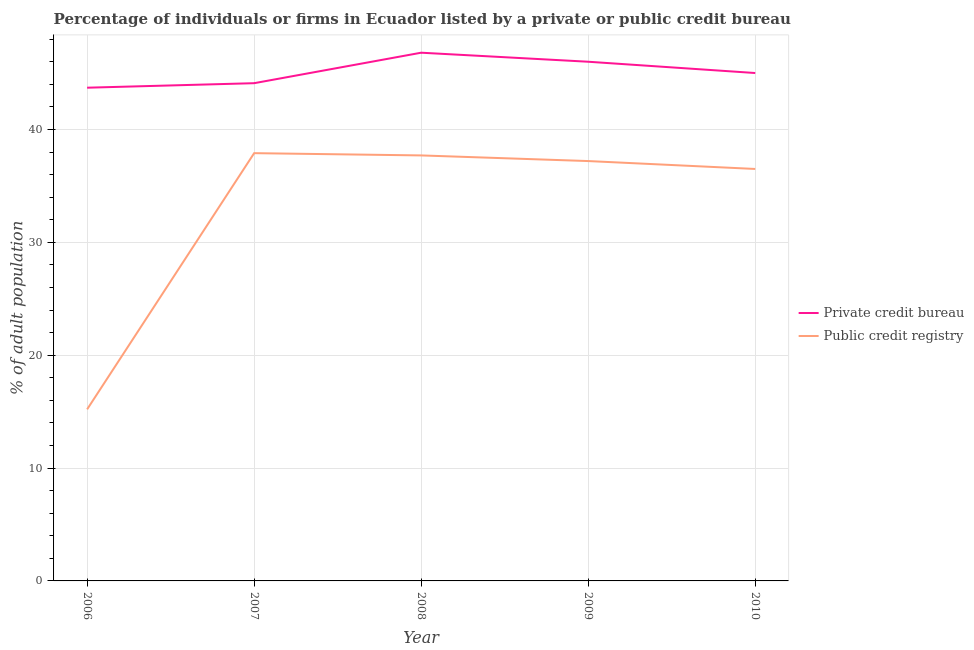How many different coloured lines are there?
Offer a terse response. 2. Is the number of lines equal to the number of legend labels?
Ensure brevity in your answer.  Yes. What is the percentage of firms listed by private credit bureau in 2007?
Your answer should be compact. 44.1. Across all years, what is the maximum percentage of firms listed by private credit bureau?
Make the answer very short. 46.8. Across all years, what is the minimum percentage of firms listed by private credit bureau?
Offer a terse response. 43.7. What is the total percentage of firms listed by public credit bureau in the graph?
Give a very brief answer. 164.5. What is the difference between the percentage of firms listed by public credit bureau in 2007 and that in 2008?
Ensure brevity in your answer.  0.2. What is the difference between the percentage of firms listed by public credit bureau in 2008 and the percentage of firms listed by private credit bureau in 2010?
Offer a very short reply. -7.3. What is the average percentage of firms listed by public credit bureau per year?
Provide a succinct answer. 32.9. In the year 2006, what is the difference between the percentage of firms listed by public credit bureau and percentage of firms listed by private credit bureau?
Your answer should be very brief. -28.5. What is the ratio of the percentage of firms listed by public credit bureau in 2006 to that in 2007?
Give a very brief answer. 0.4. Is the percentage of firms listed by private credit bureau in 2007 less than that in 2009?
Ensure brevity in your answer.  Yes. Is the difference between the percentage of firms listed by public credit bureau in 2006 and 2007 greater than the difference between the percentage of firms listed by private credit bureau in 2006 and 2007?
Offer a very short reply. No. What is the difference between the highest and the second highest percentage of firms listed by public credit bureau?
Keep it short and to the point. 0.2. What is the difference between the highest and the lowest percentage of firms listed by public credit bureau?
Provide a short and direct response. 22.7. In how many years, is the percentage of firms listed by public credit bureau greater than the average percentage of firms listed by public credit bureau taken over all years?
Your answer should be compact. 4. Is the percentage of firms listed by public credit bureau strictly less than the percentage of firms listed by private credit bureau over the years?
Keep it short and to the point. Yes. How many years are there in the graph?
Your answer should be compact. 5. What is the difference between two consecutive major ticks on the Y-axis?
Offer a terse response. 10. Are the values on the major ticks of Y-axis written in scientific E-notation?
Offer a very short reply. No. Does the graph contain grids?
Your answer should be compact. Yes. Where does the legend appear in the graph?
Offer a terse response. Center right. What is the title of the graph?
Give a very brief answer. Percentage of individuals or firms in Ecuador listed by a private or public credit bureau. What is the label or title of the X-axis?
Offer a terse response. Year. What is the label or title of the Y-axis?
Your response must be concise. % of adult population. What is the % of adult population in Private credit bureau in 2006?
Your response must be concise. 43.7. What is the % of adult population of Private credit bureau in 2007?
Offer a terse response. 44.1. What is the % of adult population in Public credit registry in 2007?
Give a very brief answer. 37.9. What is the % of adult population of Private credit bureau in 2008?
Provide a succinct answer. 46.8. What is the % of adult population in Public credit registry in 2008?
Make the answer very short. 37.7. What is the % of adult population of Private credit bureau in 2009?
Keep it short and to the point. 46. What is the % of adult population in Public credit registry in 2009?
Provide a succinct answer. 37.2. What is the % of adult population of Public credit registry in 2010?
Make the answer very short. 36.5. Across all years, what is the maximum % of adult population in Private credit bureau?
Ensure brevity in your answer.  46.8. Across all years, what is the maximum % of adult population in Public credit registry?
Keep it short and to the point. 37.9. Across all years, what is the minimum % of adult population in Private credit bureau?
Make the answer very short. 43.7. Across all years, what is the minimum % of adult population of Public credit registry?
Make the answer very short. 15.2. What is the total % of adult population in Private credit bureau in the graph?
Your answer should be compact. 225.6. What is the total % of adult population in Public credit registry in the graph?
Your answer should be very brief. 164.5. What is the difference between the % of adult population of Public credit registry in 2006 and that in 2007?
Provide a succinct answer. -22.7. What is the difference between the % of adult population in Public credit registry in 2006 and that in 2008?
Make the answer very short. -22.5. What is the difference between the % of adult population in Private credit bureau in 2006 and that in 2009?
Make the answer very short. -2.3. What is the difference between the % of adult population of Public credit registry in 2006 and that in 2010?
Ensure brevity in your answer.  -21.3. What is the difference between the % of adult population in Public credit registry in 2007 and that in 2008?
Offer a terse response. 0.2. What is the difference between the % of adult population in Public credit registry in 2007 and that in 2009?
Make the answer very short. 0.7. What is the difference between the % of adult population in Private credit bureau in 2007 and that in 2010?
Your response must be concise. -0.9. What is the difference between the % of adult population in Public credit registry in 2007 and that in 2010?
Give a very brief answer. 1.4. What is the difference between the % of adult population in Public credit registry in 2008 and that in 2009?
Offer a terse response. 0.5. What is the difference between the % of adult population of Public credit registry in 2008 and that in 2010?
Make the answer very short. 1.2. What is the difference between the % of adult population in Private credit bureau in 2006 and the % of adult population in Public credit registry in 2007?
Your answer should be compact. 5.8. What is the difference between the % of adult population in Private credit bureau in 2007 and the % of adult population in Public credit registry in 2008?
Your answer should be compact. 6.4. What is the difference between the % of adult population in Private credit bureau in 2009 and the % of adult population in Public credit registry in 2010?
Offer a very short reply. 9.5. What is the average % of adult population in Private credit bureau per year?
Your answer should be very brief. 45.12. What is the average % of adult population in Public credit registry per year?
Keep it short and to the point. 32.9. In the year 2007, what is the difference between the % of adult population of Private credit bureau and % of adult population of Public credit registry?
Keep it short and to the point. 6.2. In the year 2010, what is the difference between the % of adult population of Private credit bureau and % of adult population of Public credit registry?
Your answer should be very brief. 8.5. What is the ratio of the % of adult population of Private credit bureau in 2006 to that in 2007?
Make the answer very short. 0.99. What is the ratio of the % of adult population of Public credit registry in 2006 to that in 2007?
Your answer should be compact. 0.4. What is the ratio of the % of adult population in Private credit bureau in 2006 to that in 2008?
Your answer should be very brief. 0.93. What is the ratio of the % of adult population of Public credit registry in 2006 to that in 2008?
Make the answer very short. 0.4. What is the ratio of the % of adult population of Public credit registry in 2006 to that in 2009?
Offer a very short reply. 0.41. What is the ratio of the % of adult population in Private credit bureau in 2006 to that in 2010?
Provide a succinct answer. 0.97. What is the ratio of the % of adult population of Public credit registry in 2006 to that in 2010?
Make the answer very short. 0.42. What is the ratio of the % of adult population of Private credit bureau in 2007 to that in 2008?
Offer a terse response. 0.94. What is the ratio of the % of adult population of Public credit registry in 2007 to that in 2008?
Give a very brief answer. 1.01. What is the ratio of the % of adult population in Private credit bureau in 2007 to that in 2009?
Provide a succinct answer. 0.96. What is the ratio of the % of adult population in Public credit registry in 2007 to that in 2009?
Ensure brevity in your answer.  1.02. What is the ratio of the % of adult population in Public credit registry in 2007 to that in 2010?
Ensure brevity in your answer.  1.04. What is the ratio of the % of adult population in Private credit bureau in 2008 to that in 2009?
Your answer should be compact. 1.02. What is the ratio of the % of adult population of Public credit registry in 2008 to that in 2009?
Provide a short and direct response. 1.01. What is the ratio of the % of adult population of Private credit bureau in 2008 to that in 2010?
Make the answer very short. 1.04. What is the ratio of the % of adult population of Public credit registry in 2008 to that in 2010?
Ensure brevity in your answer.  1.03. What is the ratio of the % of adult population in Private credit bureau in 2009 to that in 2010?
Provide a succinct answer. 1.02. What is the ratio of the % of adult population in Public credit registry in 2009 to that in 2010?
Provide a short and direct response. 1.02. What is the difference between the highest and the lowest % of adult population in Public credit registry?
Keep it short and to the point. 22.7. 